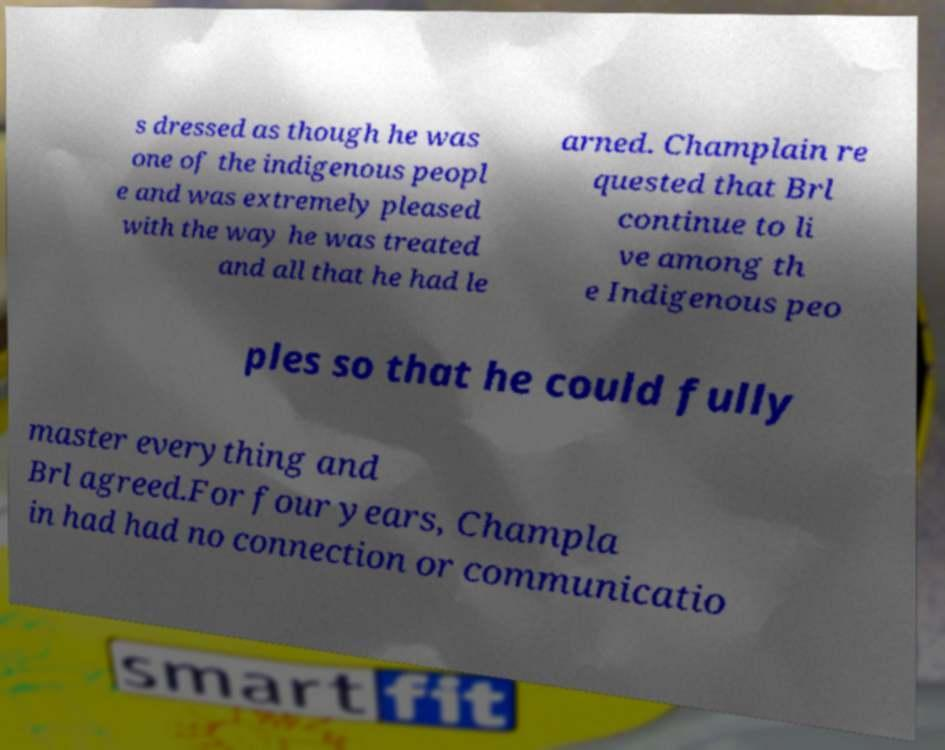Can you accurately transcribe the text from the provided image for me? s dressed as though he was one of the indigenous peopl e and was extremely pleased with the way he was treated and all that he had le arned. Champlain re quested that Brl continue to li ve among th e Indigenous peo ples so that he could fully master everything and Brl agreed.For four years, Champla in had had no connection or communicatio 